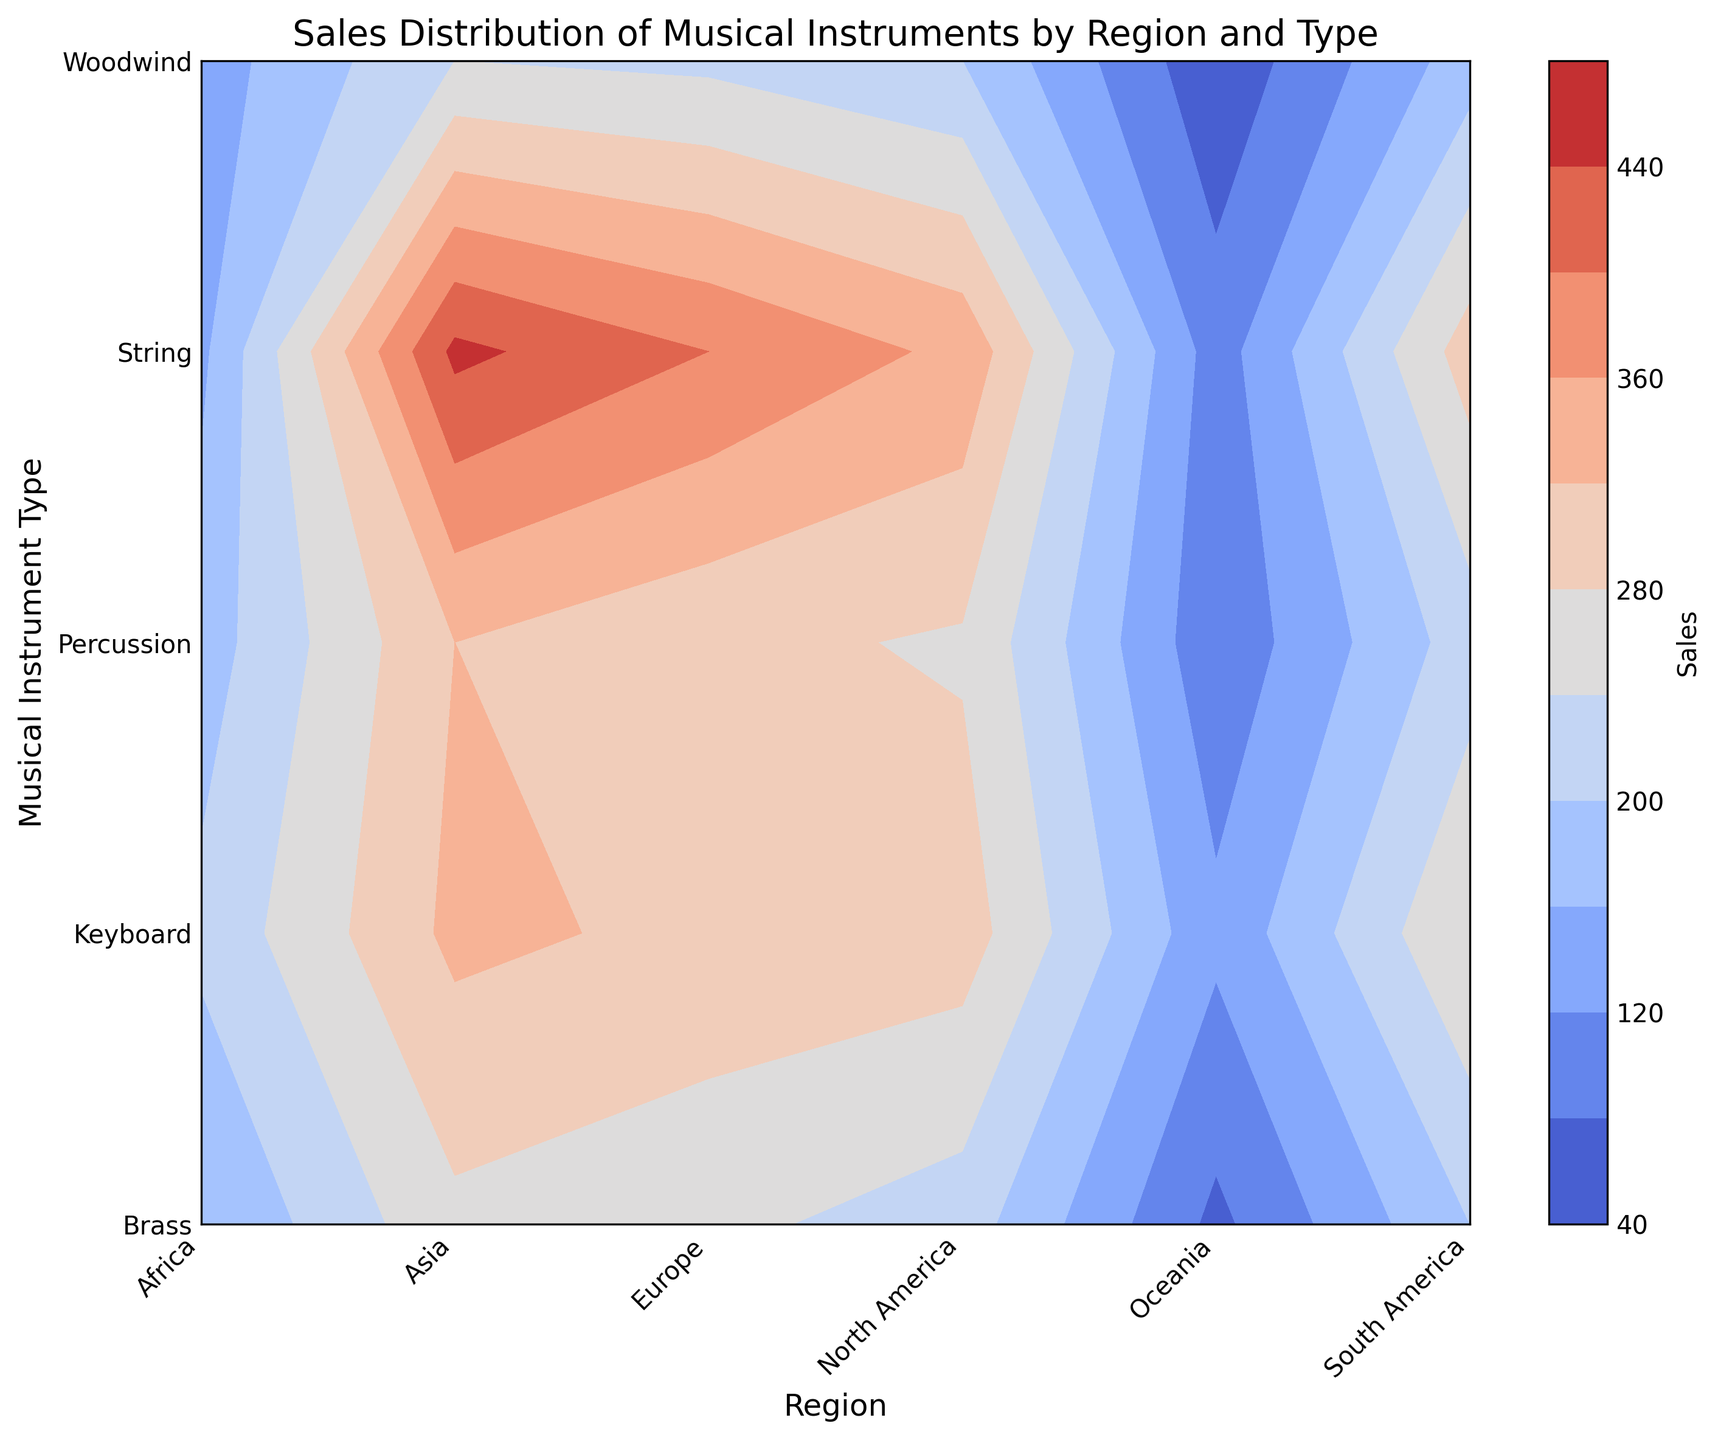Which region has the highest sales for string instruments? Look at the contour plot and identify the region on the x-axis with the highest contour level for the 'String' instrument type on the y-axis.
Answer: Asia Which type of instrument has the lowest sales in Oceania? Look at the contour plot and check the y-axis for the lowest contour level in the 'Oceania' region on the x-axis.
Answer: Woodwind Compare the sales of percussion instruments between North America and South America. Which region has higher sales? Examine the contour plot and compare the contour levels for the 'Percussion' instrument type in the 'North America' and 'South America' regions.
Answer: North America What is the average sales of keyboard instruments across all regions? Sum the sales of keyboard instruments in each region (300 + 310 + 330 + 280 + 210 + 130) and divide by the number of regions (6).
Answer: 260 Which region shows the smallest difference in sales between string and brass instruments? Calculate the difference in sales between string and brass instruments for each region by comparing the contour levels, and identify the region with the smallest numerical difference. For instance, for North America the difference is 350 - 220 = 130. Compare this for other regions.
Answer: Africa Are the sales of woodwind instruments in Asia higher than in Europe? Examine the contour plot and compare the contour levels for the 'Woodwind' instrument type in the 'Asia' and 'Europe' regions.
Answer: Yes In which region are sales relatively evenly distributed among different instrument types? Look at the contour levels for each instrument type within a region and identify which region has the most similar contour levels across all types.
Answer: Europe Which type of instrument has the most uneven sales distribution across all regions? By visually analyzing the contour plot, determine which instrument type exhibits the greatest variance in contour levels across different regions.
Answer: String What is the total sales of brass instruments in North America and South America combined? Sum the sales values for brass instruments in North America (220) and South America (200).
Answer: 420 